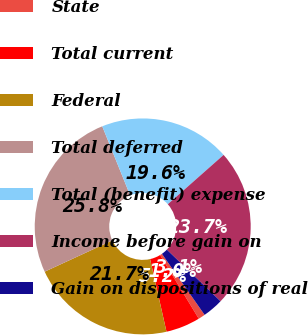Convert chart. <chart><loc_0><loc_0><loc_500><loc_500><pie_chart><fcel>State<fcel>Total current<fcel>Federal<fcel>Total deferred<fcel>Total (benefit) expense<fcel>Income before gain on<fcel>Gain on dispositions of real<nl><fcel>1.03%<fcel>5.15%<fcel>21.65%<fcel>25.77%<fcel>19.59%<fcel>23.71%<fcel>3.09%<nl></chart> 